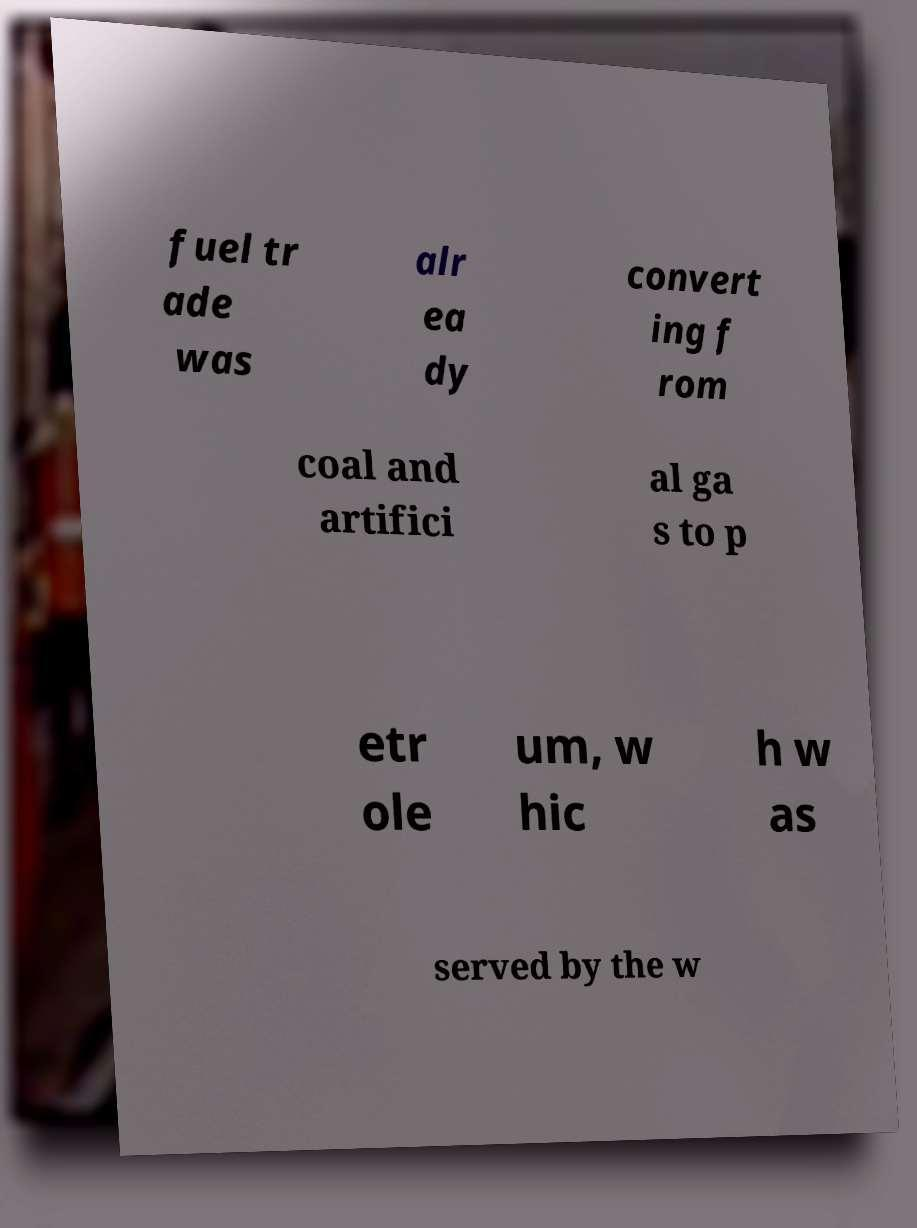Could you assist in decoding the text presented in this image and type it out clearly? fuel tr ade was alr ea dy convert ing f rom coal and artifici al ga s to p etr ole um, w hic h w as served by the w 